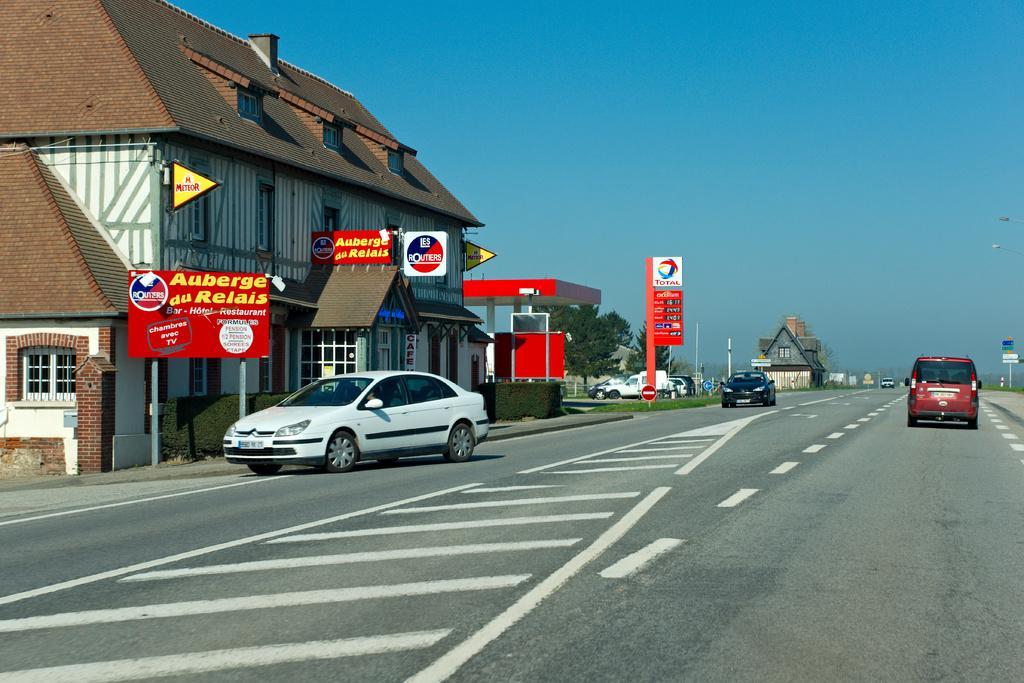In one or two sentences, can you explain what this image depicts? In this image we can see there are cars riding on the road, behind that there are buildings and petrol bunk. Also there are so many boards on the poles. 